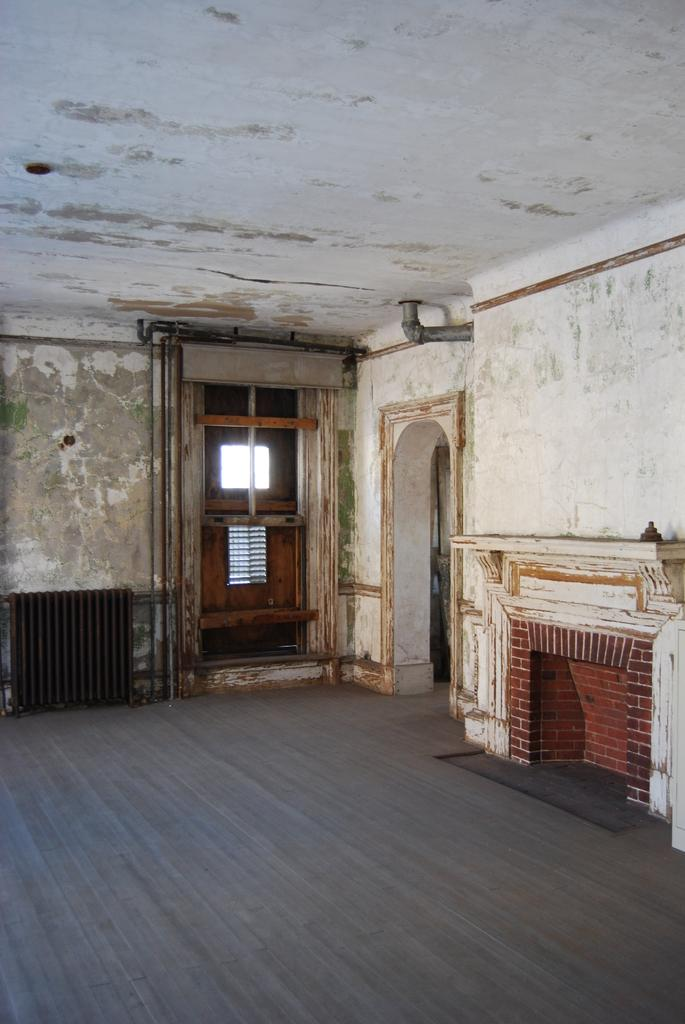What type of setting is shown in the image? The image depicts the interior of a building. What can be seen in the background of the image? There is a door in the background of the image. What architectural feature is present in the right corner of the image? There is a fireplace in the right corner of the image. What type of shade is covering the fireplace in the image? There is no shade covering the fireplace in the image; it is visible and not obstructed. 